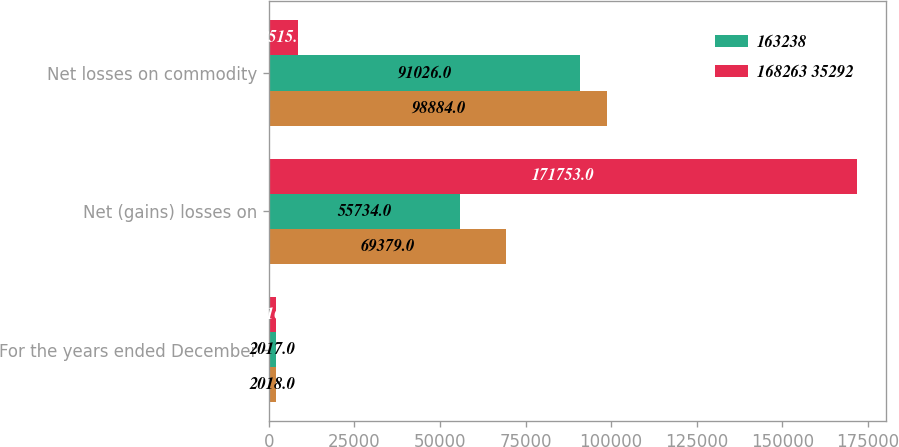Convert chart to OTSL. <chart><loc_0><loc_0><loc_500><loc_500><stacked_bar_chart><ecel><fcel>For the years ended December<fcel>Net (gains) losses on<fcel>Net losses on commodity<nl><fcel>nan<fcel>2018<fcel>69379<fcel>98884<nl><fcel>163238<fcel>2017<fcel>55734<fcel>91026<nl><fcel>168263 35292<fcel>2016<fcel>171753<fcel>8515<nl></chart> 